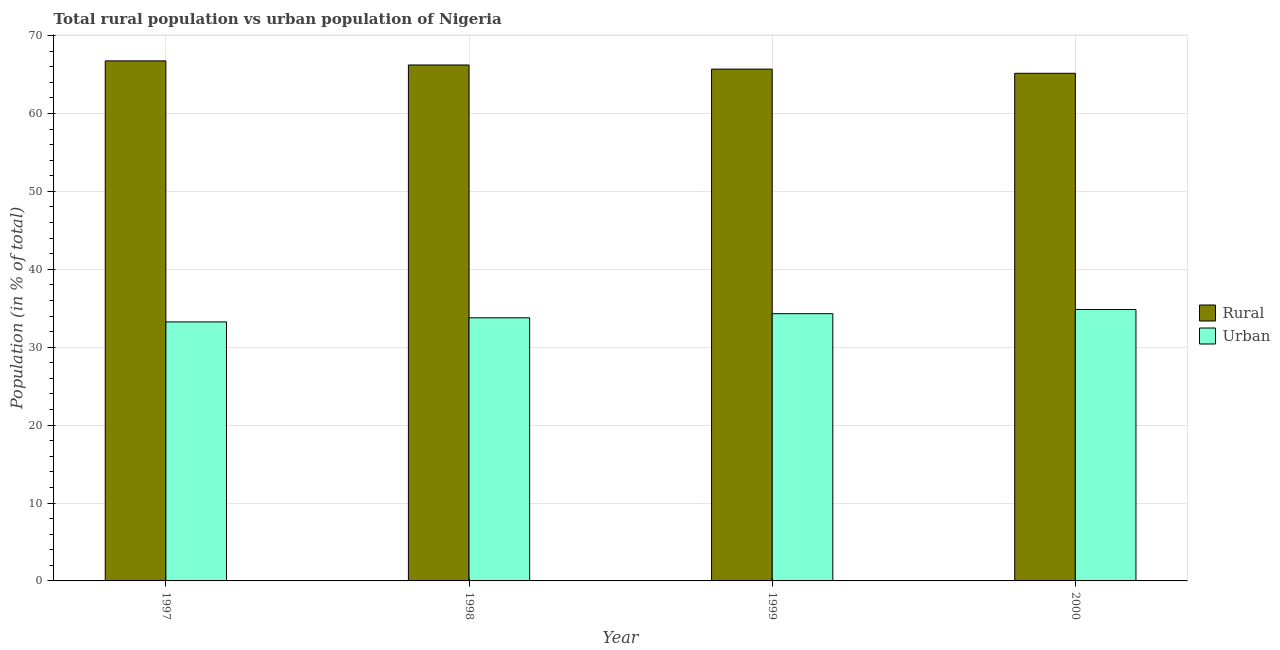Are the number of bars per tick equal to the number of legend labels?
Your response must be concise. Yes. How many bars are there on the 3rd tick from the left?
Provide a short and direct response. 2. What is the urban population in 2000?
Keep it short and to the point. 34.84. Across all years, what is the maximum urban population?
Offer a very short reply. 34.84. Across all years, what is the minimum urban population?
Offer a terse response. 33.25. In which year was the urban population maximum?
Your response must be concise. 2000. In which year was the urban population minimum?
Ensure brevity in your answer.  1997. What is the total urban population in the graph?
Your answer should be compact. 136.16. What is the difference between the urban population in 1998 and that in 1999?
Keep it short and to the point. -0.53. What is the difference between the rural population in 2000 and the urban population in 1997?
Ensure brevity in your answer.  -1.59. What is the average rural population per year?
Provide a succinct answer. 65.96. What is the ratio of the urban population in 1998 to that in 1999?
Offer a very short reply. 0.98. Is the urban population in 1997 less than that in 1999?
Ensure brevity in your answer.  Yes. What is the difference between the highest and the second highest rural population?
Offer a terse response. 0.53. What is the difference between the highest and the lowest urban population?
Give a very brief answer. 1.59. In how many years, is the urban population greater than the average urban population taken over all years?
Ensure brevity in your answer.  2. What does the 2nd bar from the left in 2000 represents?
Give a very brief answer. Urban. What does the 2nd bar from the right in 2000 represents?
Make the answer very short. Rural. Are all the bars in the graph horizontal?
Give a very brief answer. No. How many years are there in the graph?
Ensure brevity in your answer.  4. What is the difference between two consecutive major ticks on the Y-axis?
Provide a succinct answer. 10. Are the values on the major ticks of Y-axis written in scientific E-notation?
Offer a very short reply. No. What is the title of the graph?
Give a very brief answer. Total rural population vs urban population of Nigeria. Does "Net National savings" appear as one of the legend labels in the graph?
Provide a short and direct response. No. What is the label or title of the Y-axis?
Ensure brevity in your answer.  Population (in % of total). What is the Population (in % of total) in Rural in 1997?
Ensure brevity in your answer.  66.75. What is the Population (in % of total) in Urban in 1997?
Make the answer very short. 33.25. What is the Population (in % of total) in Rural in 1998?
Offer a terse response. 66.23. What is the Population (in % of total) in Urban in 1998?
Provide a succinct answer. 33.77. What is the Population (in % of total) in Rural in 1999?
Ensure brevity in your answer.  65.7. What is the Population (in % of total) of Urban in 1999?
Your answer should be compact. 34.3. What is the Population (in % of total) in Rural in 2000?
Give a very brief answer. 65.16. What is the Population (in % of total) in Urban in 2000?
Give a very brief answer. 34.84. Across all years, what is the maximum Population (in % of total) of Rural?
Provide a succinct answer. 66.75. Across all years, what is the maximum Population (in % of total) in Urban?
Your answer should be very brief. 34.84. Across all years, what is the minimum Population (in % of total) of Rural?
Your response must be concise. 65.16. Across all years, what is the minimum Population (in % of total) of Urban?
Ensure brevity in your answer.  33.25. What is the total Population (in % of total) of Rural in the graph?
Offer a very short reply. 263.84. What is the total Population (in % of total) in Urban in the graph?
Your answer should be compact. 136.16. What is the difference between the Population (in % of total) in Rural in 1997 and that in 1998?
Your answer should be compact. 0.53. What is the difference between the Population (in % of total) in Urban in 1997 and that in 1998?
Provide a short and direct response. -0.53. What is the difference between the Population (in % of total) in Rural in 1997 and that in 1999?
Your answer should be compact. 1.06. What is the difference between the Population (in % of total) in Urban in 1997 and that in 1999?
Offer a very short reply. -1.06. What is the difference between the Population (in % of total) of Rural in 1997 and that in 2000?
Your answer should be very brief. 1.59. What is the difference between the Population (in % of total) of Urban in 1997 and that in 2000?
Keep it short and to the point. -1.59. What is the difference between the Population (in % of total) in Rural in 1998 and that in 1999?
Your answer should be compact. 0.53. What is the difference between the Population (in % of total) of Urban in 1998 and that in 1999?
Provide a succinct answer. -0.53. What is the difference between the Population (in % of total) in Rural in 1998 and that in 2000?
Give a very brief answer. 1.07. What is the difference between the Population (in % of total) in Urban in 1998 and that in 2000?
Provide a short and direct response. -1.07. What is the difference between the Population (in % of total) of Rural in 1999 and that in 2000?
Keep it short and to the point. 0.54. What is the difference between the Population (in % of total) in Urban in 1999 and that in 2000?
Ensure brevity in your answer.  -0.54. What is the difference between the Population (in % of total) of Rural in 1997 and the Population (in % of total) of Urban in 1998?
Provide a succinct answer. 32.98. What is the difference between the Population (in % of total) in Rural in 1997 and the Population (in % of total) in Urban in 1999?
Provide a succinct answer. 32.45. What is the difference between the Population (in % of total) of Rural in 1997 and the Population (in % of total) of Urban in 2000?
Your response must be concise. 31.91. What is the difference between the Population (in % of total) in Rural in 1998 and the Population (in % of total) in Urban in 1999?
Provide a short and direct response. 31.92. What is the difference between the Population (in % of total) of Rural in 1998 and the Population (in % of total) of Urban in 2000?
Ensure brevity in your answer.  31.39. What is the difference between the Population (in % of total) in Rural in 1999 and the Population (in % of total) in Urban in 2000?
Offer a terse response. 30.86. What is the average Population (in % of total) of Rural per year?
Offer a very short reply. 65.96. What is the average Population (in % of total) in Urban per year?
Keep it short and to the point. 34.04. In the year 1997, what is the difference between the Population (in % of total) in Rural and Population (in % of total) in Urban?
Provide a succinct answer. 33.51. In the year 1998, what is the difference between the Population (in % of total) in Rural and Population (in % of total) in Urban?
Make the answer very short. 32.45. In the year 1999, what is the difference between the Population (in % of total) of Rural and Population (in % of total) of Urban?
Give a very brief answer. 31.39. In the year 2000, what is the difference between the Population (in % of total) in Rural and Population (in % of total) in Urban?
Offer a very short reply. 30.32. What is the ratio of the Population (in % of total) of Rural in 1997 to that in 1998?
Offer a terse response. 1.01. What is the ratio of the Population (in % of total) in Urban in 1997 to that in 1998?
Keep it short and to the point. 0.98. What is the ratio of the Population (in % of total) of Rural in 1997 to that in 1999?
Your response must be concise. 1.02. What is the ratio of the Population (in % of total) of Urban in 1997 to that in 1999?
Provide a short and direct response. 0.97. What is the ratio of the Population (in % of total) of Rural in 1997 to that in 2000?
Make the answer very short. 1.02. What is the ratio of the Population (in % of total) of Urban in 1997 to that in 2000?
Offer a very short reply. 0.95. What is the ratio of the Population (in % of total) in Rural in 1998 to that in 1999?
Provide a succinct answer. 1.01. What is the ratio of the Population (in % of total) in Urban in 1998 to that in 1999?
Offer a terse response. 0.98. What is the ratio of the Population (in % of total) of Rural in 1998 to that in 2000?
Offer a very short reply. 1.02. What is the ratio of the Population (in % of total) of Urban in 1998 to that in 2000?
Your answer should be compact. 0.97. What is the ratio of the Population (in % of total) of Rural in 1999 to that in 2000?
Your answer should be compact. 1.01. What is the ratio of the Population (in % of total) in Urban in 1999 to that in 2000?
Offer a terse response. 0.98. What is the difference between the highest and the second highest Population (in % of total) in Rural?
Provide a short and direct response. 0.53. What is the difference between the highest and the second highest Population (in % of total) of Urban?
Provide a short and direct response. 0.54. What is the difference between the highest and the lowest Population (in % of total) of Rural?
Your response must be concise. 1.59. What is the difference between the highest and the lowest Population (in % of total) of Urban?
Give a very brief answer. 1.59. 